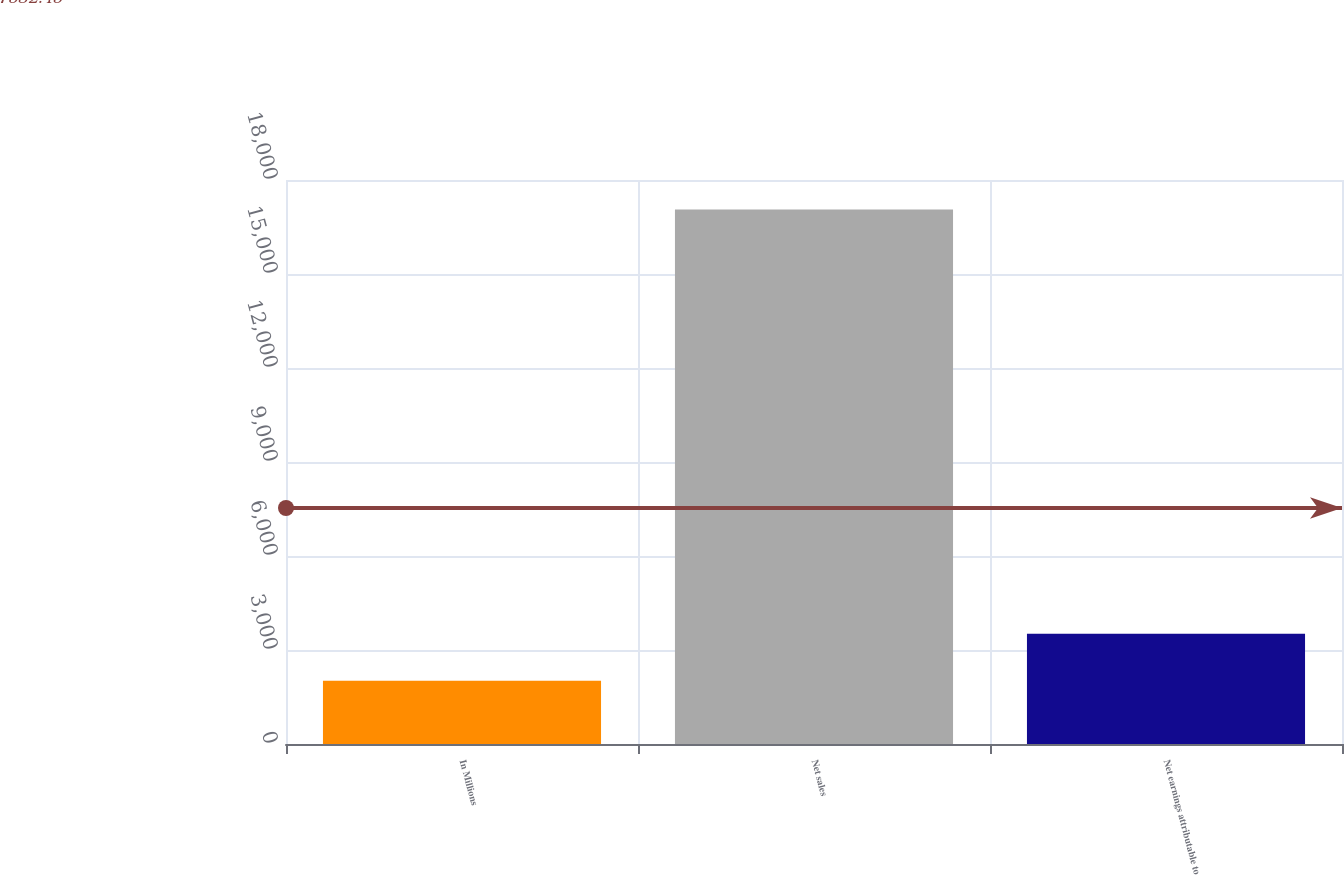Convert chart. <chart><loc_0><loc_0><loc_500><loc_500><bar_chart><fcel>In Millions<fcel>Net sales<fcel>Net earnings attributable to<nl><fcel>2018<fcel>17057.4<fcel>3521.94<nl></chart> 